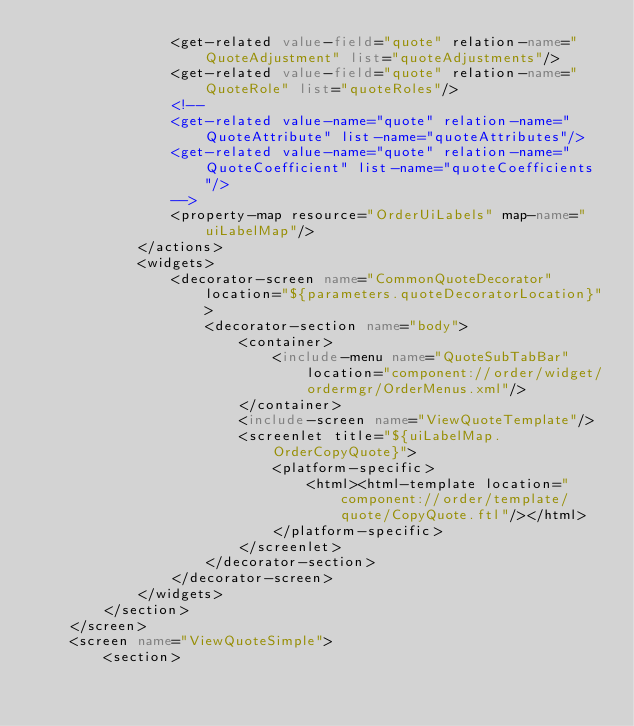Convert code to text. <code><loc_0><loc_0><loc_500><loc_500><_XML_>                <get-related value-field="quote" relation-name="QuoteAdjustment" list="quoteAdjustments"/>
                <get-related value-field="quote" relation-name="QuoteRole" list="quoteRoles"/>
                <!--
                <get-related value-name="quote" relation-name="QuoteAttribute" list-name="quoteAttributes"/>
                <get-related value-name="quote" relation-name="QuoteCoefficient" list-name="quoteCoefficients"/>
                -->
                <property-map resource="OrderUiLabels" map-name="uiLabelMap"/>
            </actions>
            <widgets>
                <decorator-screen name="CommonQuoteDecorator" location="${parameters.quoteDecoratorLocation}">
                    <decorator-section name="body">
                        <container>
                            <include-menu name="QuoteSubTabBar" location="component://order/widget/ordermgr/OrderMenus.xml"/>
                        </container>
                        <include-screen name="ViewQuoteTemplate"/>
                        <screenlet title="${uiLabelMap.OrderCopyQuote}">
                            <platform-specific>
                                <html><html-template location="component://order/template/quote/CopyQuote.ftl"/></html>
                            </platform-specific>
                        </screenlet>
                    </decorator-section>
                </decorator-screen>
            </widgets>
        </section>
    </screen>
    <screen name="ViewQuoteSimple">
        <section></code> 